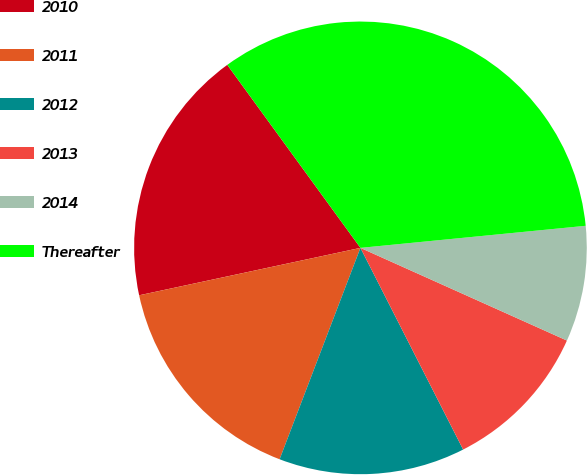<chart> <loc_0><loc_0><loc_500><loc_500><pie_chart><fcel>2010<fcel>2011<fcel>2012<fcel>2013<fcel>2014<fcel>Thereafter<nl><fcel>18.35%<fcel>15.83%<fcel>13.31%<fcel>10.79%<fcel>8.27%<fcel>33.46%<nl></chart> 